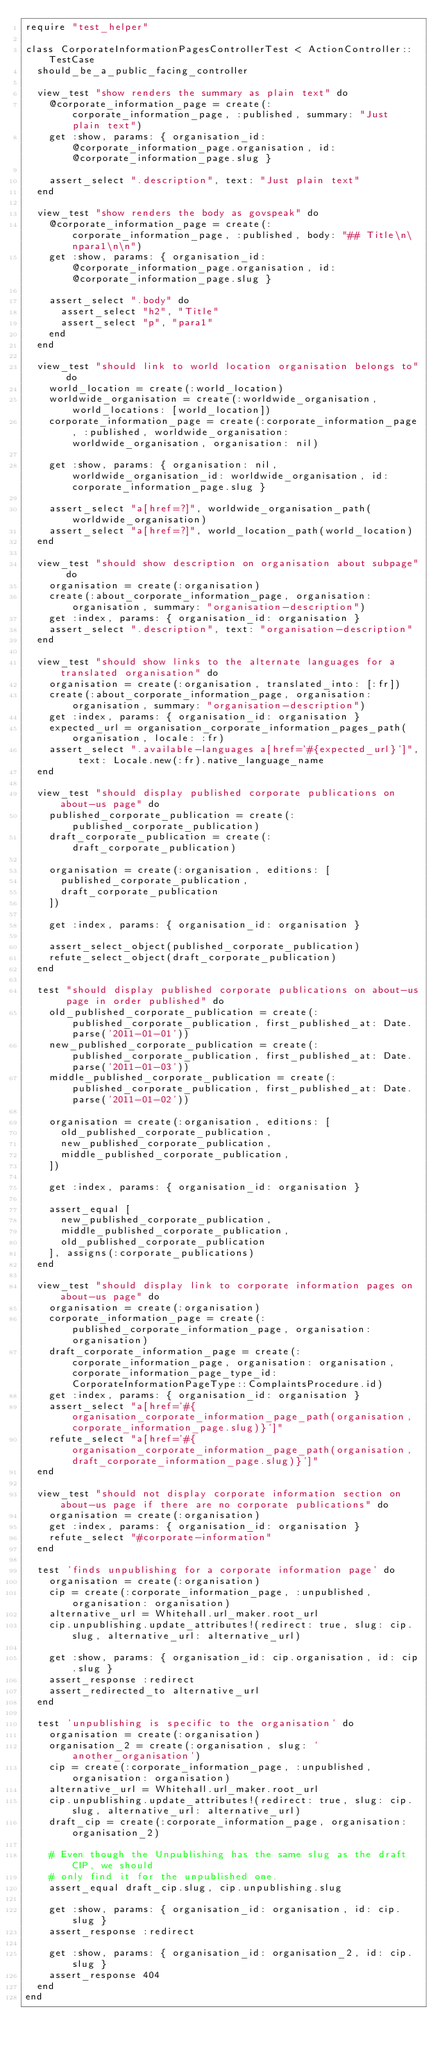<code> <loc_0><loc_0><loc_500><loc_500><_Ruby_>require "test_helper"

class CorporateInformationPagesControllerTest < ActionController::TestCase
  should_be_a_public_facing_controller

  view_test "show renders the summary as plain text" do
    @corporate_information_page = create(:corporate_information_page, :published, summary: "Just plain text")
    get :show, params: { organisation_id: @corporate_information_page.organisation, id: @corporate_information_page.slug }

    assert_select ".description", text: "Just plain text"
  end

  view_test "show renders the body as govspeak" do
    @corporate_information_page = create(:corporate_information_page, :published, body: "## Title\n\npara1\n\n")
    get :show, params: { organisation_id: @corporate_information_page.organisation, id: @corporate_information_page.slug }

    assert_select ".body" do
      assert_select "h2", "Title"
      assert_select "p", "para1"
    end
  end

  view_test "should link to world location organisation belongs to" do
    world_location = create(:world_location)
    worldwide_organisation = create(:worldwide_organisation, world_locations: [world_location])
    corporate_information_page = create(:corporate_information_page, :published, worldwide_organisation: worldwide_organisation, organisation: nil)

    get :show, params: { organisation: nil, worldwide_organisation_id: worldwide_organisation, id: corporate_information_page.slug }

    assert_select "a[href=?]", worldwide_organisation_path(worldwide_organisation)
    assert_select "a[href=?]", world_location_path(world_location)
  end

  view_test "should show description on organisation about subpage" do
    organisation = create(:organisation)
    create(:about_corporate_information_page, organisation: organisation, summary: "organisation-description")
    get :index, params: { organisation_id: organisation }
    assert_select ".description", text: "organisation-description"
  end

  view_test "should show links to the alternate languages for a translated organisation" do
    organisation = create(:organisation, translated_into: [:fr])
    create(:about_corporate_information_page, organisation: organisation, summary: "organisation-description")
    get :index, params: { organisation_id: organisation }
    expected_url = organisation_corporate_information_pages_path(organisation, locale: :fr)
    assert_select ".available-languages a[href='#{expected_url}']", text: Locale.new(:fr).native_language_name
  end

  view_test "should display published corporate publications on about-us page" do
    published_corporate_publication = create(:published_corporate_publication)
    draft_corporate_publication = create(:draft_corporate_publication)

    organisation = create(:organisation, editions: [
      published_corporate_publication,
      draft_corporate_publication
    ])

    get :index, params: { organisation_id: organisation }

    assert_select_object(published_corporate_publication)
    refute_select_object(draft_corporate_publication)
  end

  test "should display published corporate publications on about-us page in order published" do
    old_published_corporate_publication = create(:published_corporate_publication, first_published_at: Date.parse('2011-01-01'))
    new_published_corporate_publication = create(:published_corporate_publication, first_published_at: Date.parse('2011-01-03'))
    middle_published_corporate_publication = create(:published_corporate_publication, first_published_at: Date.parse('2011-01-02'))

    organisation = create(:organisation, editions: [
      old_published_corporate_publication,
      new_published_corporate_publication,
      middle_published_corporate_publication,
    ])

    get :index, params: { organisation_id: organisation }

    assert_equal [
      new_published_corporate_publication,
      middle_published_corporate_publication,
      old_published_corporate_publication
    ], assigns(:corporate_publications)
  end

  view_test "should display link to corporate information pages on about-us page" do
    organisation = create(:organisation)
    corporate_information_page = create(:published_corporate_information_page, organisation: organisation)
    draft_corporate_information_page = create(:corporate_information_page, organisation: organisation, corporate_information_page_type_id: CorporateInformationPageType::ComplaintsProcedure.id)
    get :index, params: { organisation_id: organisation }
    assert_select "a[href='#{organisation_corporate_information_page_path(organisation, corporate_information_page.slug)}']"
    refute_select "a[href='#{organisation_corporate_information_page_path(organisation, draft_corporate_information_page.slug)}']"
  end

  view_test "should not display corporate information section on about-us page if there are no corporate publications" do
    organisation = create(:organisation)
    get :index, params: { organisation_id: organisation }
    refute_select "#corporate-information"
  end

  test 'finds unpublishing for a corporate information page' do
    organisation = create(:organisation)
    cip = create(:corporate_information_page, :unpublished, organisation: organisation)
    alternative_url = Whitehall.url_maker.root_url
    cip.unpublishing.update_attributes!(redirect: true, slug: cip.slug, alternative_url: alternative_url)

    get :show, params: { organisation_id: cip.organisation, id: cip.slug }
    assert_response :redirect
    assert_redirected_to alternative_url
  end

  test 'unpublishing is specific to the organisation' do
    organisation = create(:organisation)
    organisation_2 = create(:organisation, slug: 'another_organisation')
    cip = create(:corporate_information_page, :unpublished, organisation: organisation)
    alternative_url = Whitehall.url_maker.root_url
    cip.unpublishing.update_attributes!(redirect: true, slug: cip.slug, alternative_url: alternative_url)
    draft_cip = create(:corporate_information_page, organisation: organisation_2)

    # Even though the Unpublishing has the same slug as the draft CIP, we should
    # only find it for the unpublished one.
    assert_equal draft_cip.slug, cip.unpublishing.slug

    get :show, params: { organisation_id: organisation, id: cip.slug }
    assert_response :redirect

    get :show, params: { organisation_id: organisation_2, id: cip.slug }
    assert_response 404
  end
end
</code> 